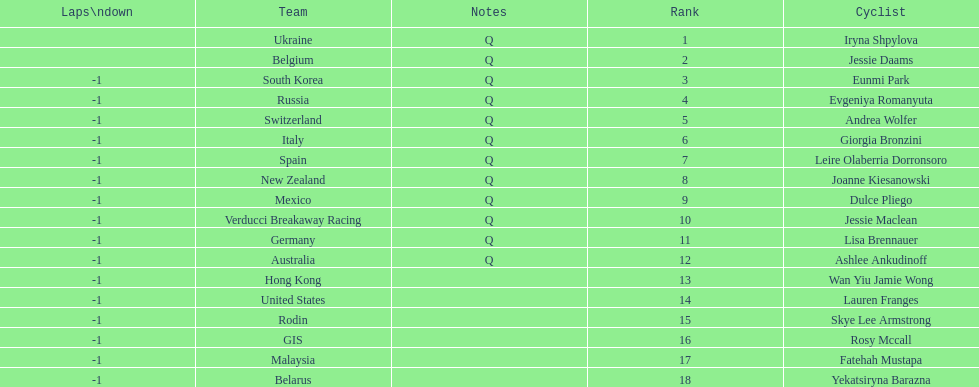What two cyclists come from teams with no laps down? Iryna Shpylova, Jessie Daams. 